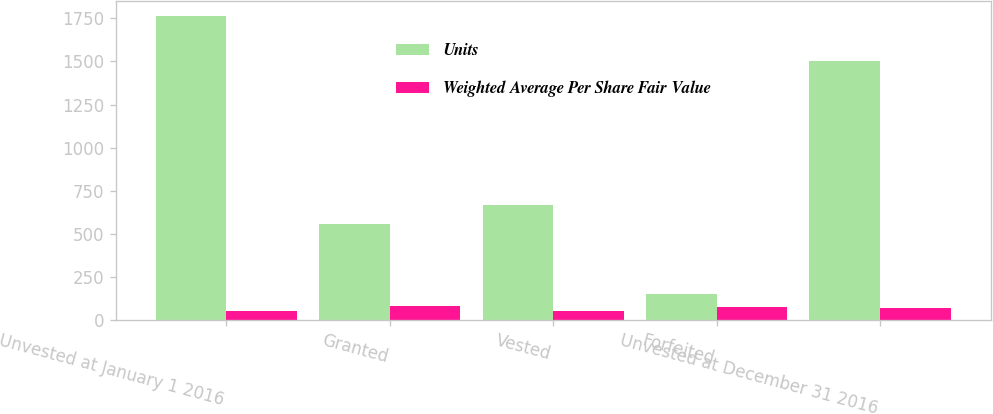Convert chart. <chart><loc_0><loc_0><loc_500><loc_500><stacked_bar_chart><ecel><fcel>Unvested at January 1 2016<fcel>Granted<fcel>Vested<fcel>Forfeited<fcel>Unvested at December 31 2016<nl><fcel>Units<fcel>1762<fcel>555<fcel>664<fcel>148<fcel>1505<nl><fcel>Weighted Average Per Share Fair Value<fcel>52.9<fcel>79.27<fcel>48.38<fcel>76.01<fcel>68.98<nl></chart> 